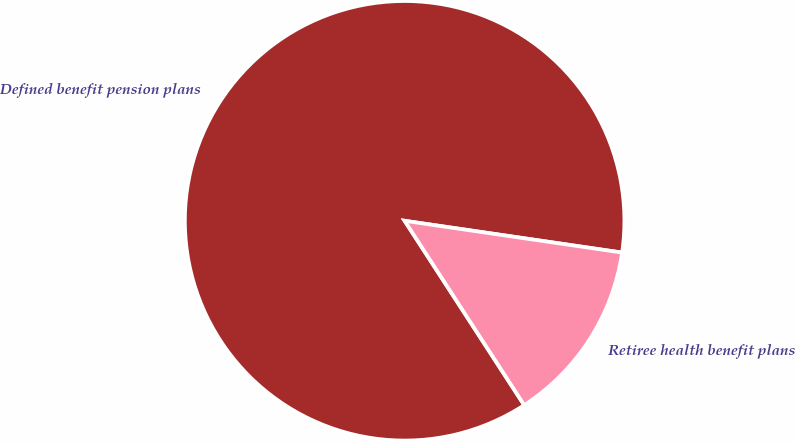Convert chart to OTSL. <chart><loc_0><loc_0><loc_500><loc_500><pie_chart><fcel>Defined benefit pension plans<fcel>Retiree health benefit plans<nl><fcel>86.47%<fcel>13.53%<nl></chart> 